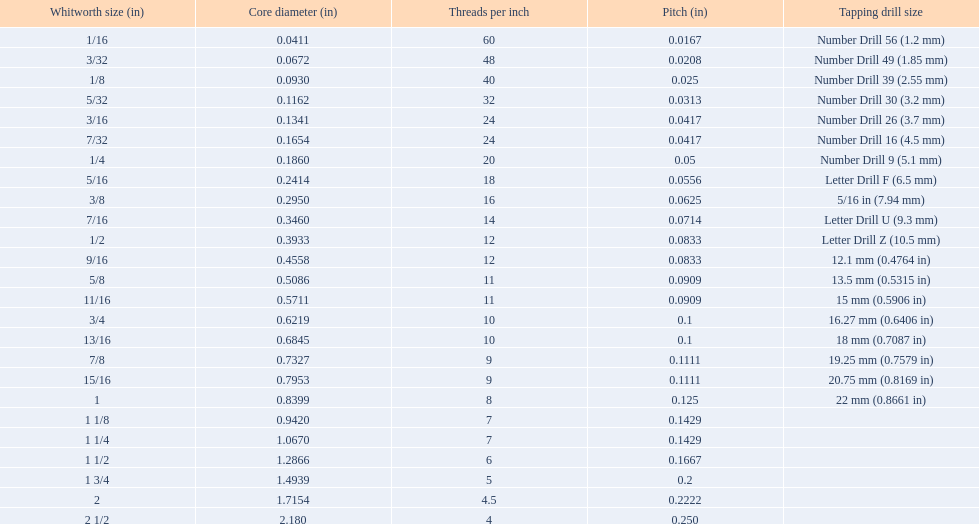What is the central diameter for the number drill 26? 0.1341. What is the whitworth size (in) for this central diameter? 3/16. 